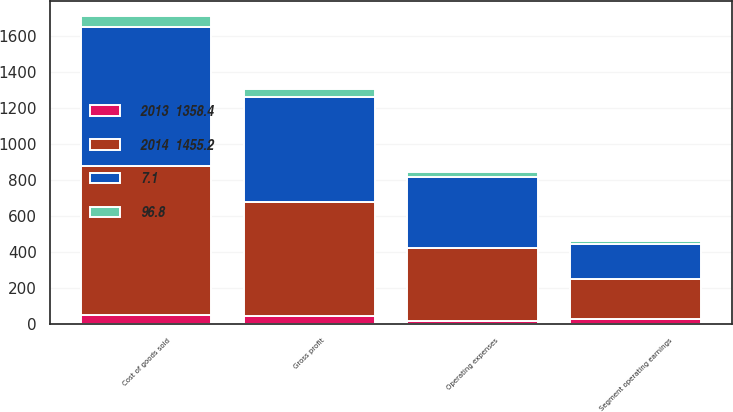Convert chart. <chart><loc_0><loc_0><loc_500><loc_500><stacked_bar_chart><ecel><fcel>Cost of goods sold<fcel>Gross profit<fcel>Operating expenses<fcel>Segment operating earnings<nl><fcel>2014  1455.2<fcel>824.9<fcel>630.3<fcel>407.2<fcel>223.1<nl><fcel>96.8<fcel>56.7<fcel>43.3<fcel>28<fcel>15.3<nl><fcel>7.1<fcel>772.6<fcel>585.8<fcel>391.2<fcel>194.6<nl><fcel>2013  1358.4<fcel>52.3<fcel>44.5<fcel>16<fcel>28.5<nl></chart> 